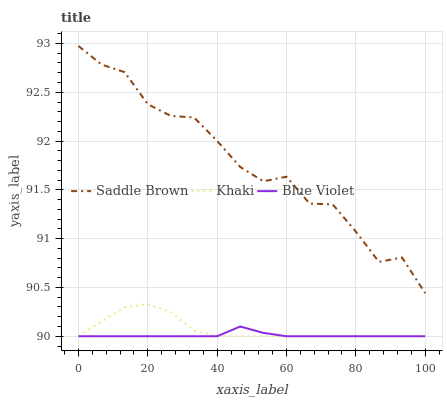Does Blue Violet have the minimum area under the curve?
Answer yes or no. Yes. Does Saddle Brown have the maximum area under the curve?
Answer yes or no. Yes. Does Saddle Brown have the minimum area under the curve?
Answer yes or no. No. Does Blue Violet have the maximum area under the curve?
Answer yes or no. No. Is Blue Violet the smoothest?
Answer yes or no. Yes. Is Saddle Brown the roughest?
Answer yes or no. Yes. Is Saddle Brown the smoothest?
Answer yes or no. No. Is Blue Violet the roughest?
Answer yes or no. No. Does Khaki have the lowest value?
Answer yes or no. Yes. Does Saddle Brown have the lowest value?
Answer yes or no. No. Does Saddle Brown have the highest value?
Answer yes or no. Yes. Does Blue Violet have the highest value?
Answer yes or no. No. Is Blue Violet less than Saddle Brown?
Answer yes or no. Yes. Is Saddle Brown greater than Khaki?
Answer yes or no. Yes. Does Khaki intersect Blue Violet?
Answer yes or no. Yes. Is Khaki less than Blue Violet?
Answer yes or no. No. Is Khaki greater than Blue Violet?
Answer yes or no. No. Does Blue Violet intersect Saddle Brown?
Answer yes or no. No. 